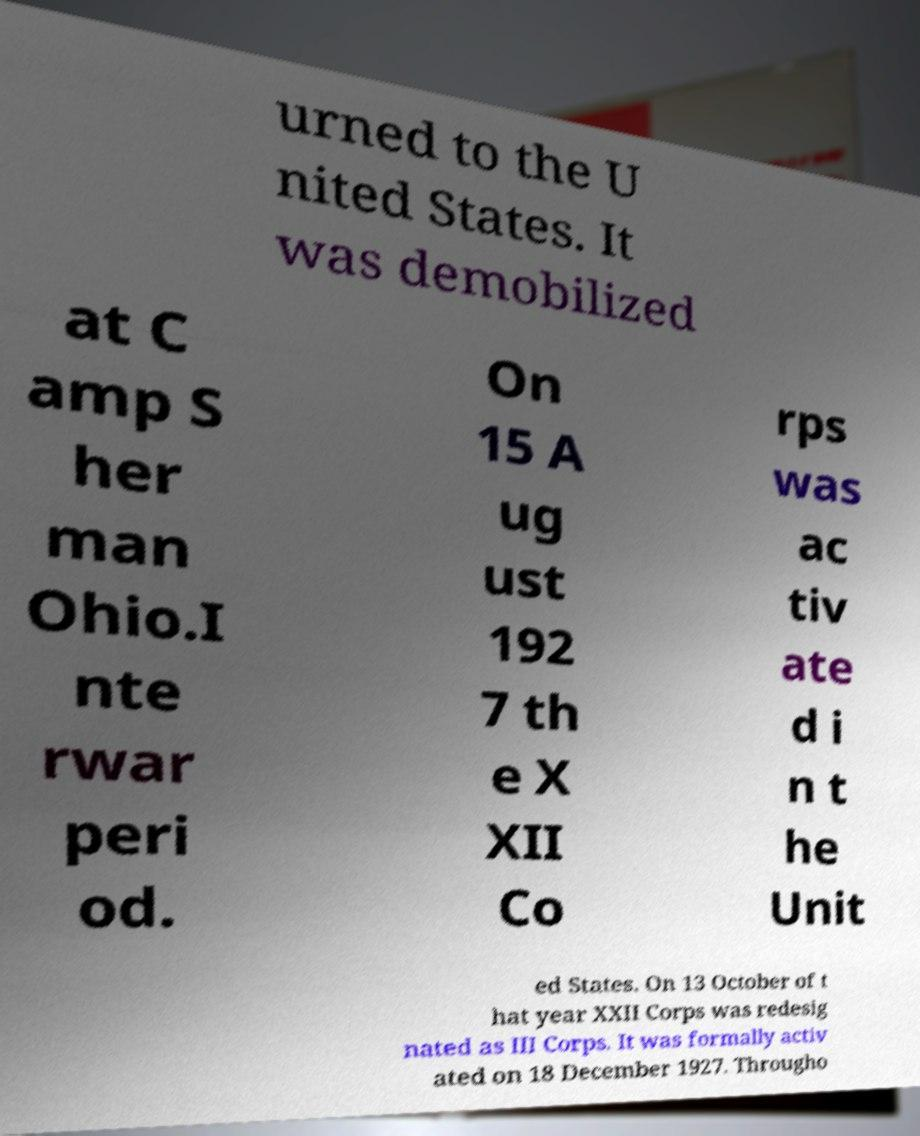I need the written content from this picture converted into text. Can you do that? urned to the U nited States. It was demobilized at C amp S her man Ohio.I nte rwar peri od. On 15 A ug ust 192 7 th e X XII Co rps was ac tiv ate d i n t he Unit ed States. On 13 October of t hat year XXII Corps was redesig nated as III Corps. It was formally activ ated on 18 December 1927. Througho 